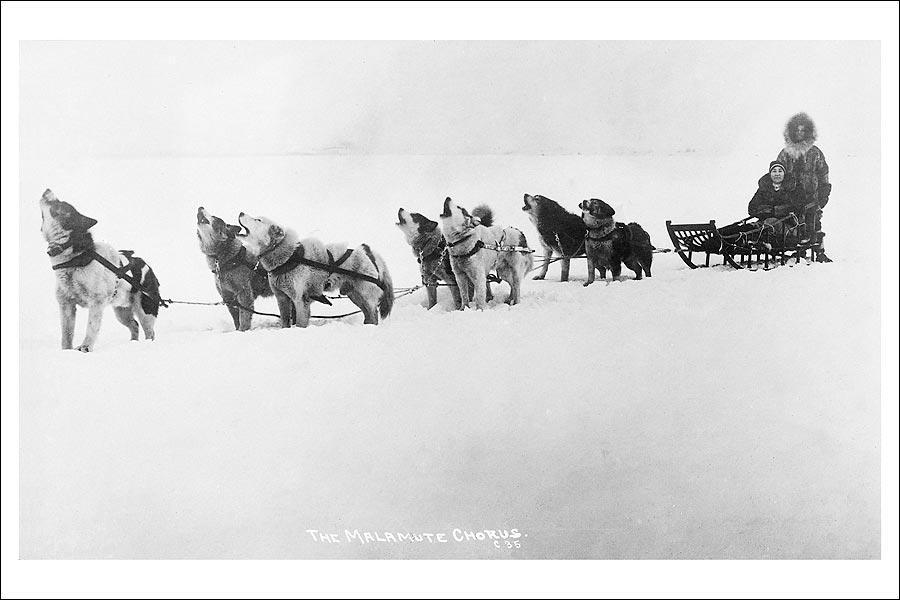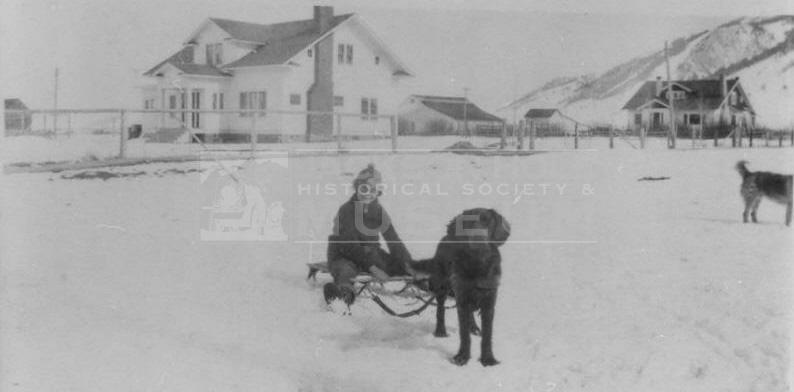The first image is the image on the left, the second image is the image on the right. Evaluate the accuracy of this statement regarding the images: "The left image shows a fur-hooded sled driver standing behind an old-fashioned long wooden sled, and the right image shows a dog sled near buildings.". Is it true? Answer yes or no. Yes. 